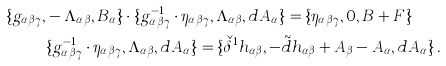<formula> <loc_0><loc_0><loc_500><loc_500>\{ g _ { \alpha \beta \gamma } , & - \Lambda _ { \alpha \beta } , B _ { \alpha } \} \cdot \{ g _ { \alpha \beta \gamma } ^ { - 1 } \cdot \eta _ { \alpha \beta \gamma } , \Lambda _ { \alpha \beta } , d A _ { \alpha } \} = \{ \eta _ { \alpha \beta \gamma } , 0 , B + F \} \\ & \{ g _ { \alpha \beta \gamma } ^ { - 1 } \cdot \eta _ { \alpha \beta \gamma } , \Lambda _ { \alpha \beta } , d A _ { \alpha } \} = \{ \check { \delta } ^ { 1 } h _ { \alpha \beta } , - \tilde { d } h _ { \alpha \beta } + A _ { \beta } - A _ { \alpha } , d A _ { \alpha } \} \, .</formula> 